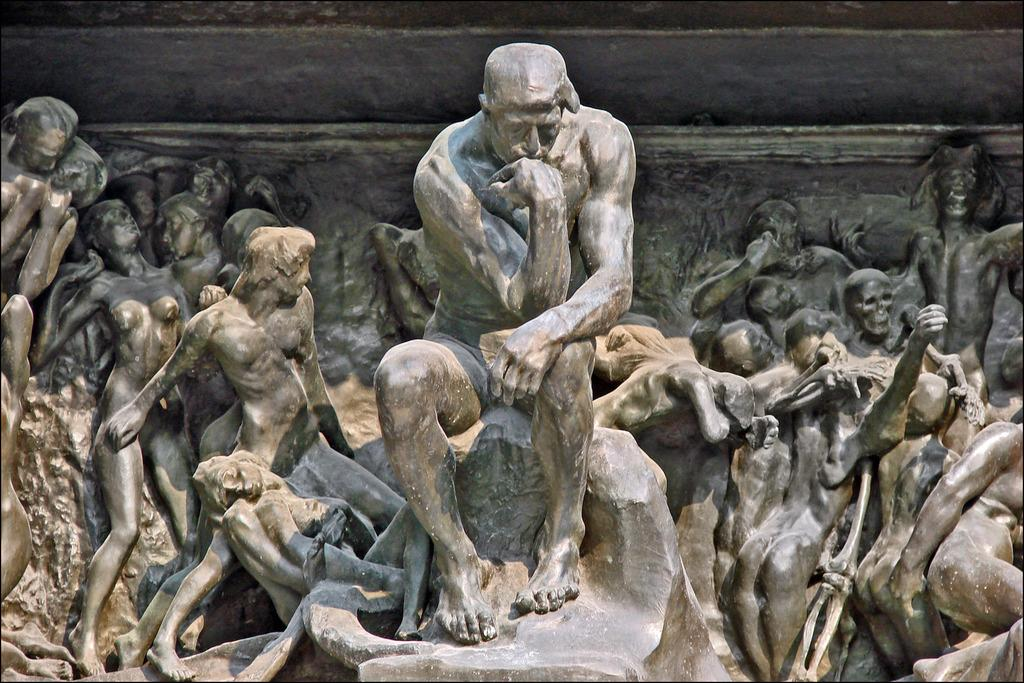What type of objects are depicted in the image? There are people sculptures in the image. Can you describe any other elements in the image? There is a part of a wall visible in the image. What type of transport is being used by the aunt in the image? There is no aunt or transport present in the image; it only features people sculptures and a part of a wall. 